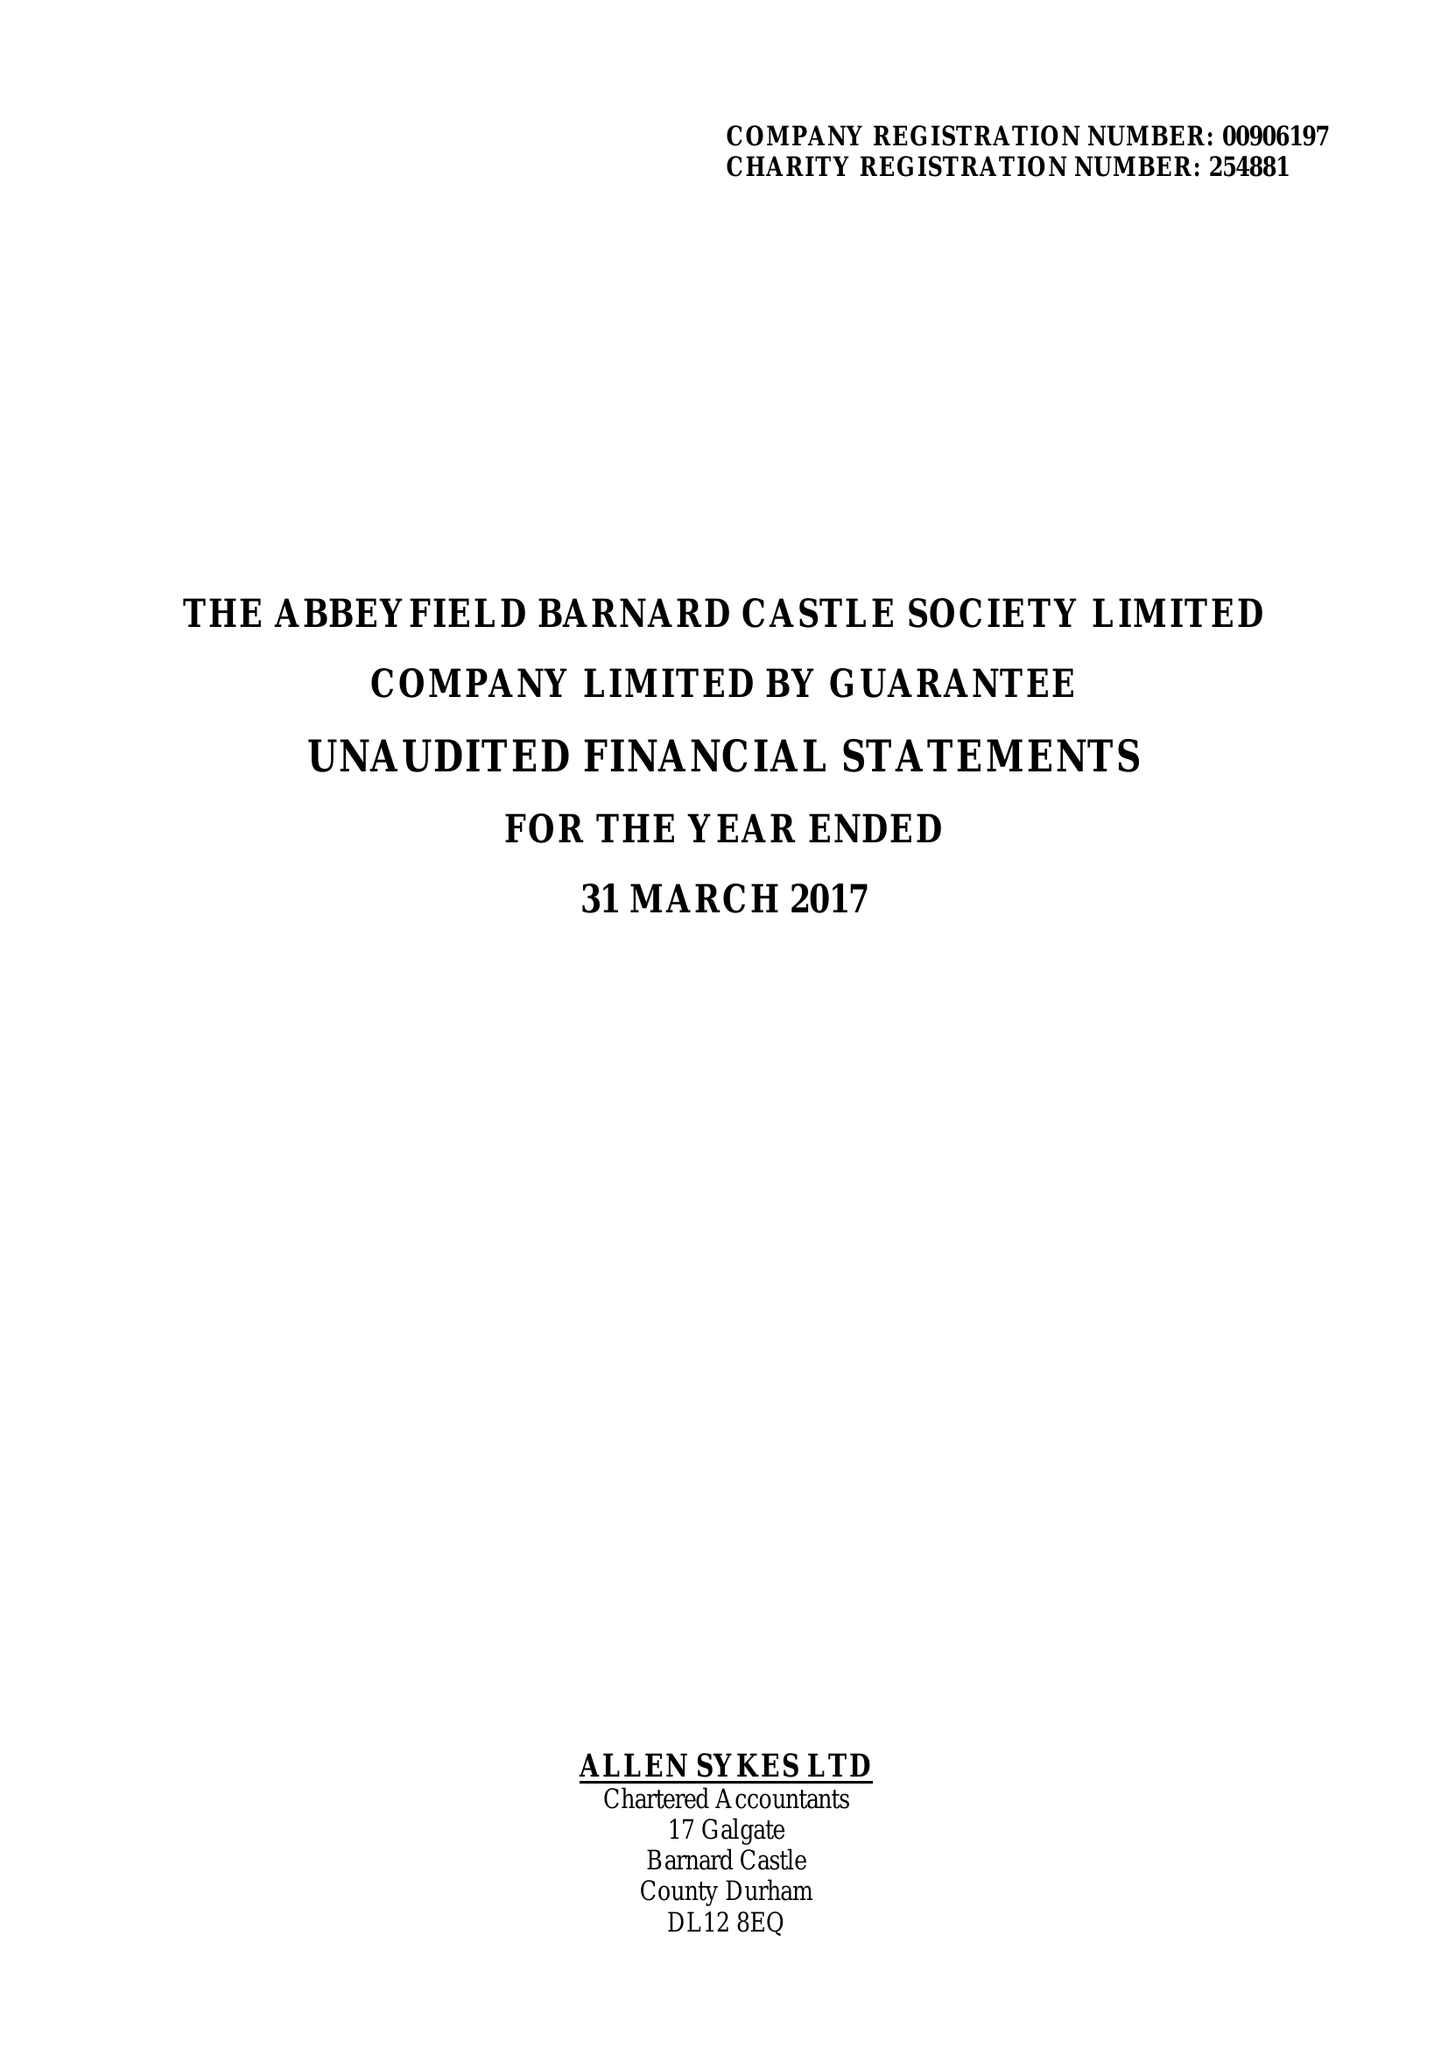What is the value for the address__postcode?
Answer the question using a single word or phrase. DL12 8BL 